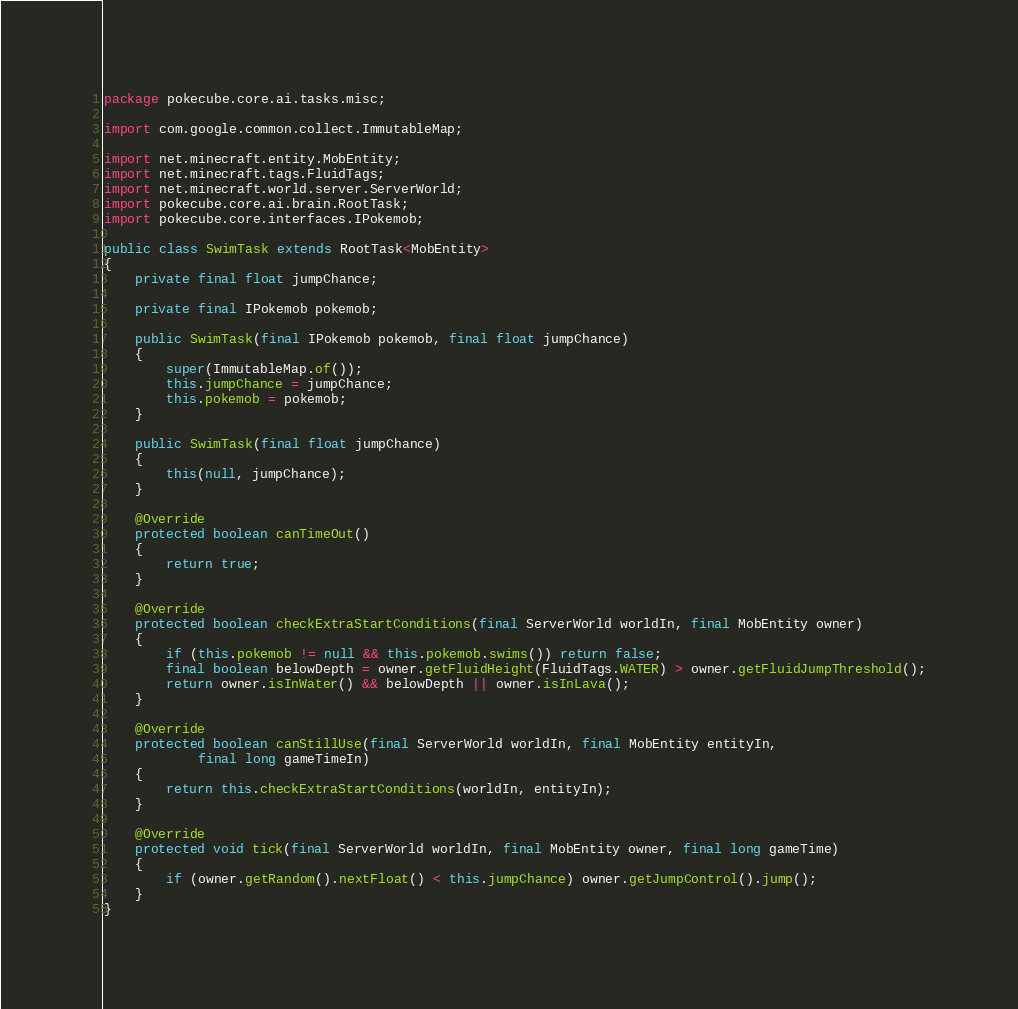<code> <loc_0><loc_0><loc_500><loc_500><_Java_>package pokecube.core.ai.tasks.misc;

import com.google.common.collect.ImmutableMap;

import net.minecraft.entity.MobEntity;
import net.minecraft.tags.FluidTags;
import net.minecraft.world.server.ServerWorld;
import pokecube.core.ai.brain.RootTask;
import pokecube.core.interfaces.IPokemob;

public class SwimTask extends RootTask<MobEntity>
{
    private final float jumpChance;

    private final IPokemob pokemob;

    public SwimTask(final IPokemob pokemob, final float jumpChance)
    {
        super(ImmutableMap.of());
        this.jumpChance = jumpChance;
        this.pokemob = pokemob;
    }

    public SwimTask(final float jumpChance)
    {
        this(null, jumpChance);
    }

    @Override
    protected boolean canTimeOut()
    {
        return true;
    }

    @Override
    protected boolean checkExtraStartConditions(final ServerWorld worldIn, final MobEntity owner)
    {
        if (this.pokemob != null && this.pokemob.swims()) return false;
        final boolean belowDepth = owner.getFluidHeight(FluidTags.WATER) > owner.getFluidJumpThreshold();
        return owner.isInWater() && belowDepth || owner.isInLava();
    }

    @Override
    protected boolean canStillUse(final ServerWorld worldIn, final MobEntity entityIn,
            final long gameTimeIn)
    {
        return this.checkExtraStartConditions(worldIn, entityIn);
    }

    @Override
    protected void tick(final ServerWorld worldIn, final MobEntity owner, final long gameTime)
    {
        if (owner.getRandom().nextFloat() < this.jumpChance) owner.getJumpControl().jump();
    }
}
</code> 